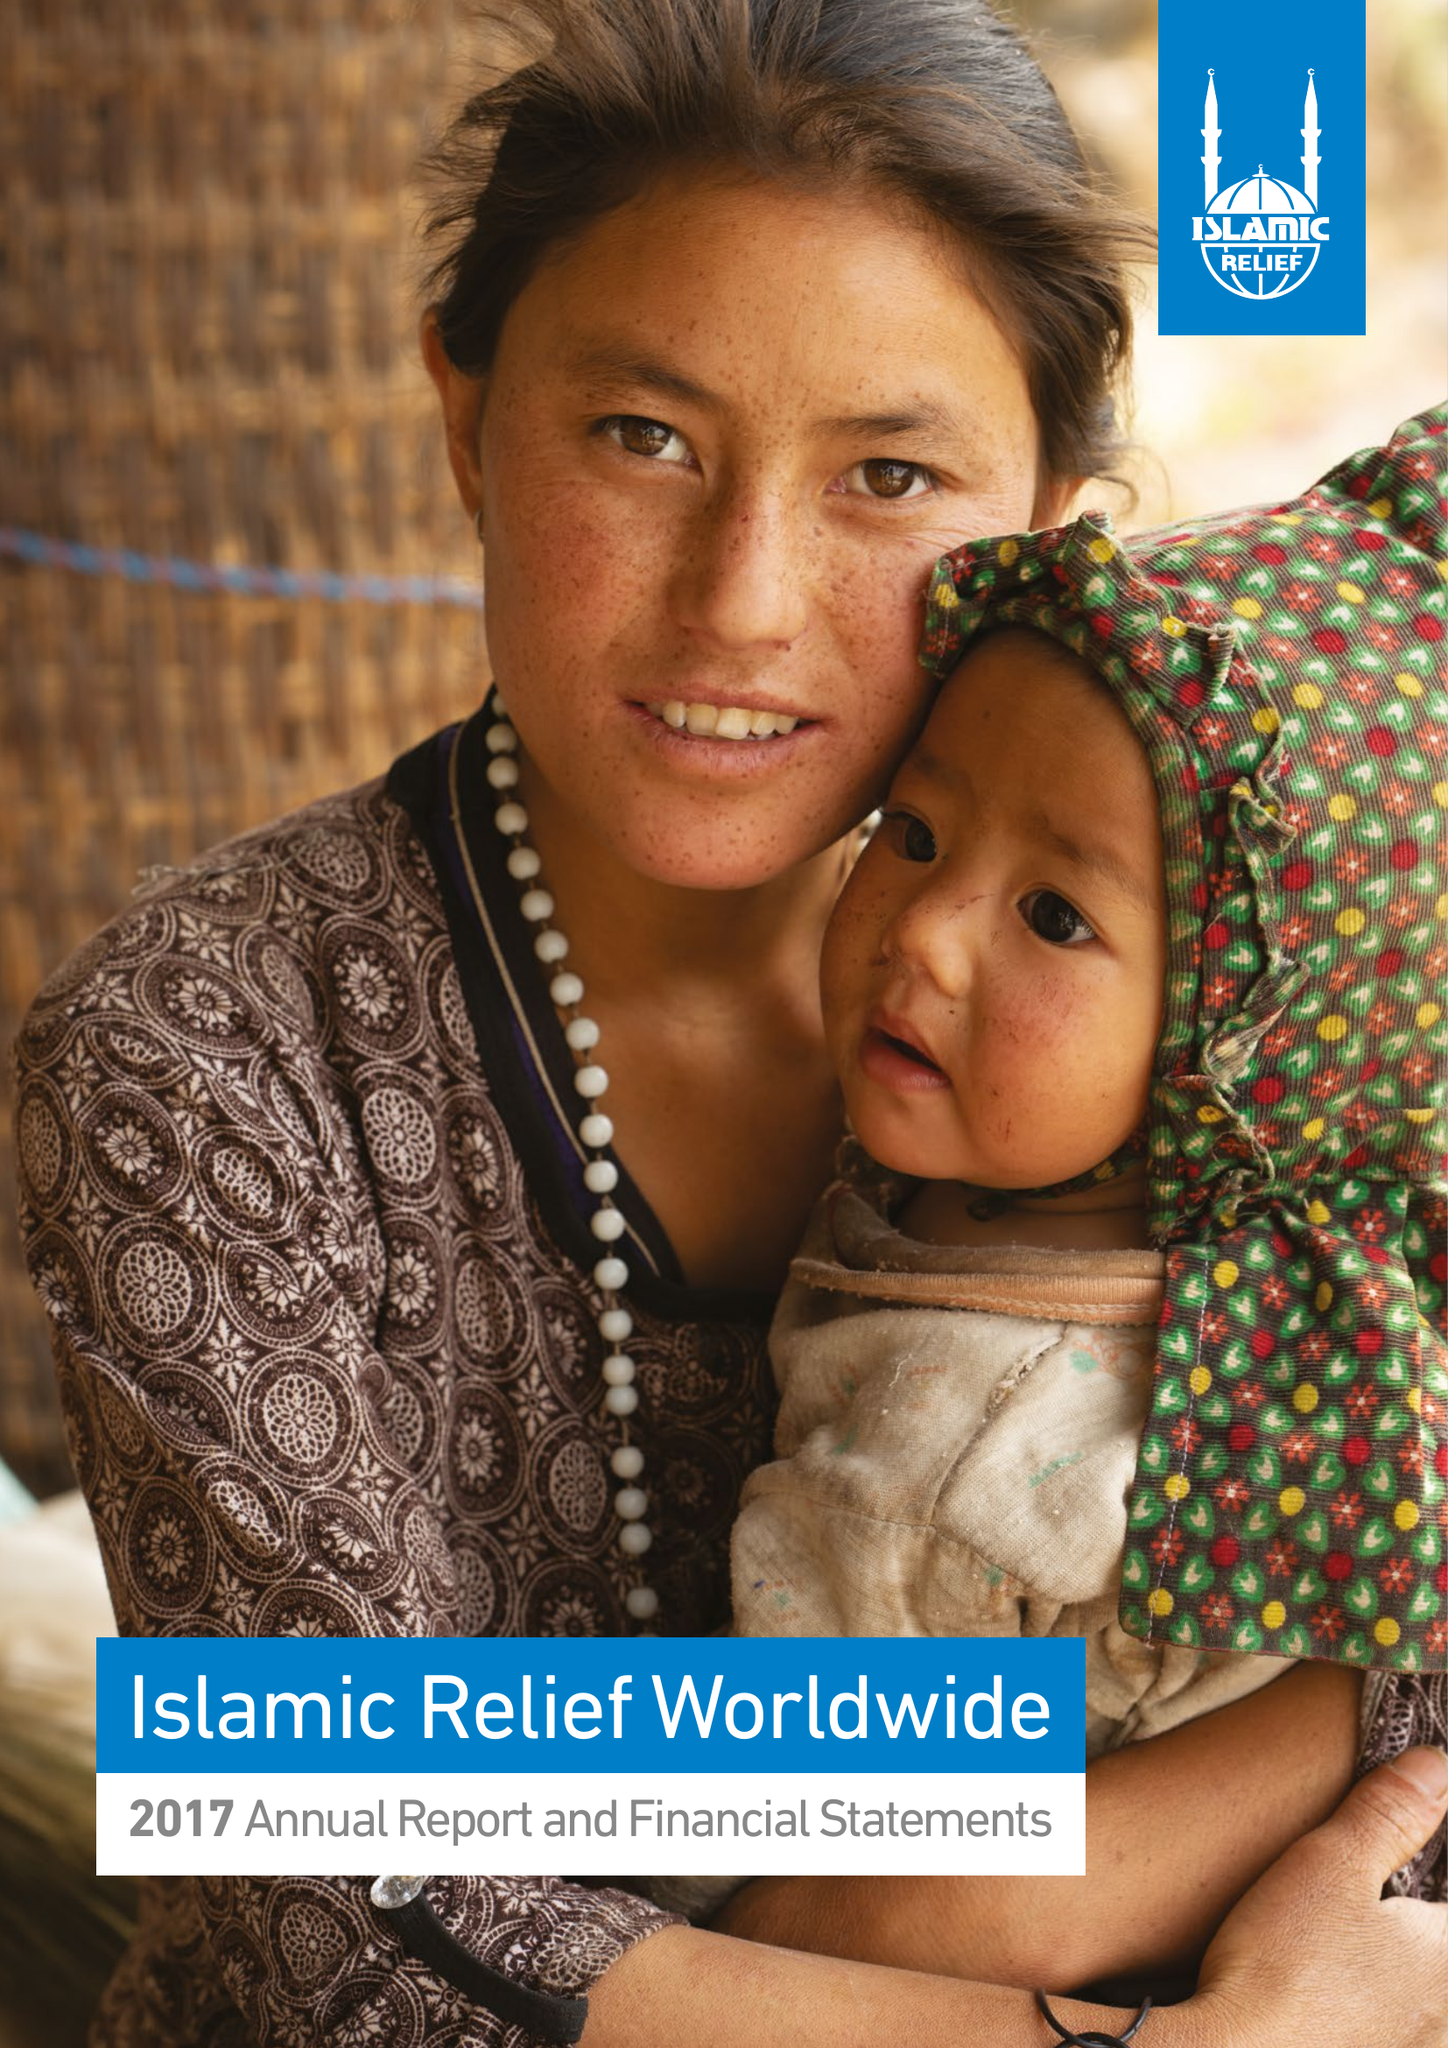What is the value for the charity_number?
Answer the question using a single word or phrase. 328158 